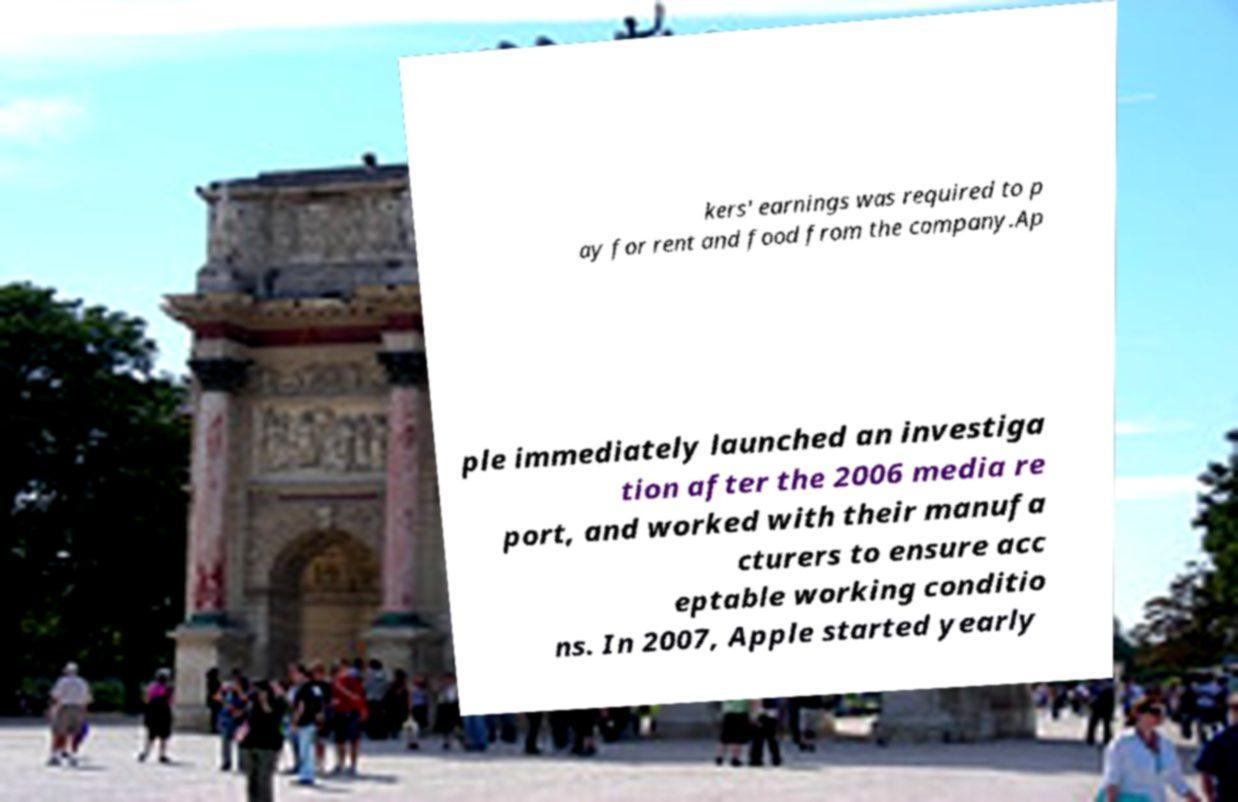Please read and relay the text visible in this image. What does it say? kers' earnings was required to p ay for rent and food from the company.Ap ple immediately launched an investiga tion after the 2006 media re port, and worked with their manufa cturers to ensure acc eptable working conditio ns. In 2007, Apple started yearly 